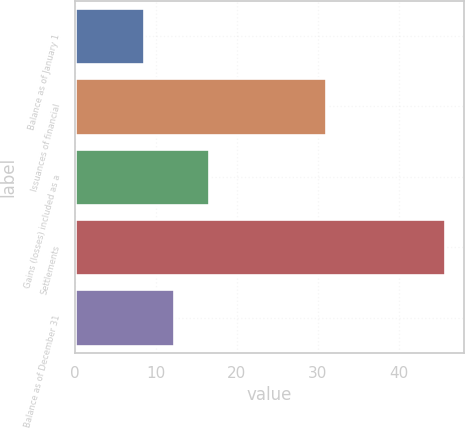Convert chart. <chart><loc_0><loc_0><loc_500><loc_500><bar_chart><fcel>Balance as of January 1<fcel>Issuances of financial<fcel>Gains (losses) included as a<fcel>Settlements<fcel>Balance as of December 31<nl><fcel>8.5<fcel>31<fcel>16.5<fcel>45.8<fcel>12.23<nl></chart> 